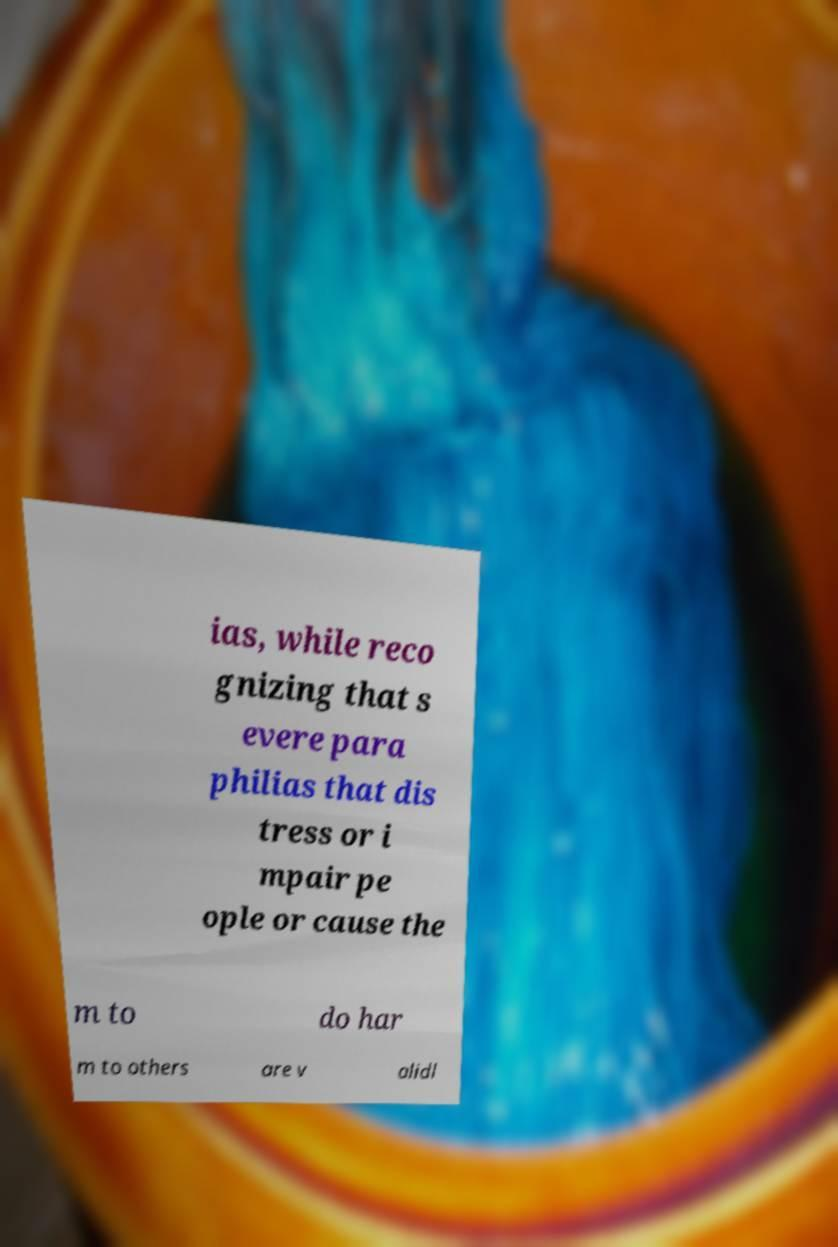For documentation purposes, I need the text within this image transcribed. Could you provide that? ias, while reco gnizing that s evere para philias that dis tress or i mpair pe ople or cause the m to do har m to others are v alidl 